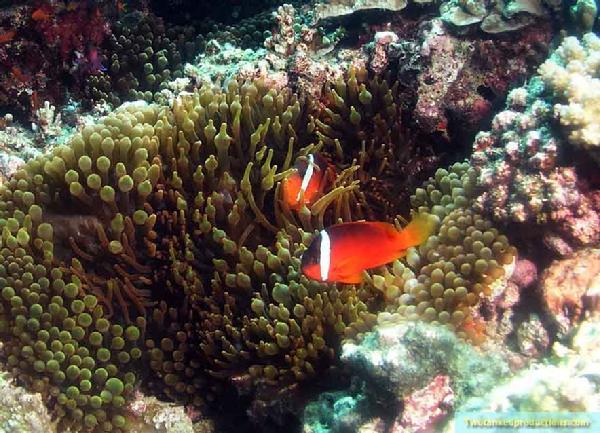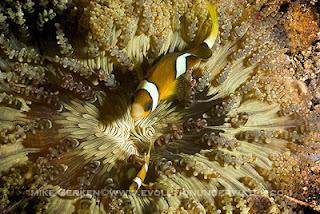The first image is the image on the left, the second image is the image on the right. Considering the images on both sides, is "One image includes two close together fish that are bright orange with white stripe, and the other image includes a yellower fish with white stripes." valid? Answer yes or no. Yes. The first image is the image on the left, the second image is the image on the right. For the images shown, is this caption "There are two orange fish in one of the images." true? Answer yes or no. Yes. 